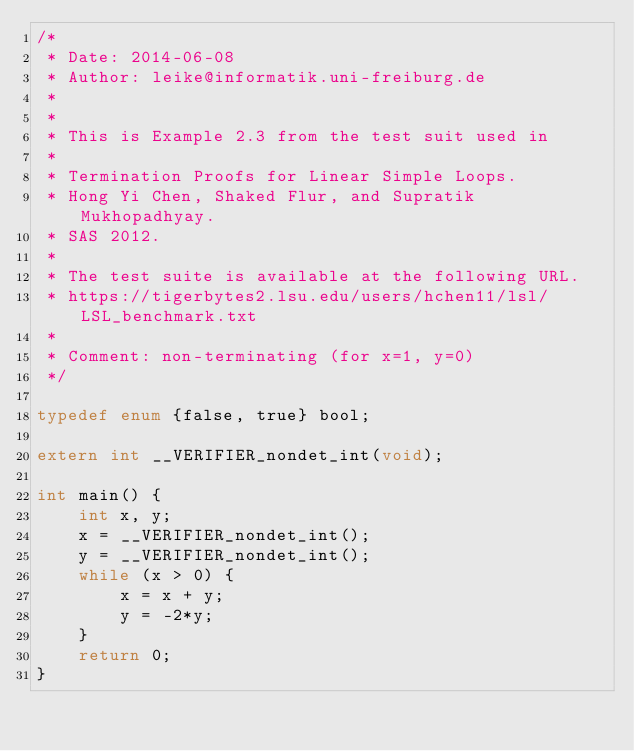<code> <loc_0><loc_0><loc_500><loc_500><_C_>/*
 * Date: 2014-06-08
 * Author: leike@informatik.uni-freiburg.de
 *
 *
 * This is Example 2.3 from the test suit used in
 *
 * Termination Proofs for Linear Simple Loops.
 * Hong Yi Chen, Shaked Flur, and Supratik Mukhopadhyay.
 * SAS 2012.
 *
 * The test suite is available at the following URL.
 * https://tigerbytes2.lsu.edu/users/hchen11/lsl/LSL_benchmark.txt
 *
 * Comment: non-terminating (for x=1, y=0)
 */

typedef enum {false, true} bool;

extern int __VERIFIER_nondet_int(void);

int main() {
    int x, y;
    x = __VERIFIER_nondet_int();
    y = __VERIFIER_nondet_int();
    while (x > 0) {
        x = x + y;
        y = -2*y;
    }
    return 0;
}
</code> 